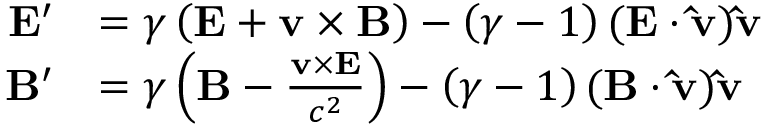<formula> <loc_0><loc_0><loc_500><loc_500>{ \begin{array} { r l } { E ^ { \prime } } & { = \gamma \left ( E + v \times B \right ) - \left ( { \gamma - 1 } \right ) ( E \cdot \hat { v } ) \hat { v } } \\ { B ^ { \prime } } & { = \gamma \left ( B - { \frac { v \times E } { c ^ { 2 } } } \right ) - \left ( { \gamma - 1 } \right ) ( B \cdot \hat { v } ) \hat { v } } \end{array} }</formula> 